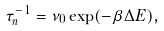<formula> <loc_0><loc_0><loc_500><loc_500>\tau _ { n } ^ { - 1 } = \nu _ { 0 } \exp ( - \beta \Delta E ) ,</formula> 